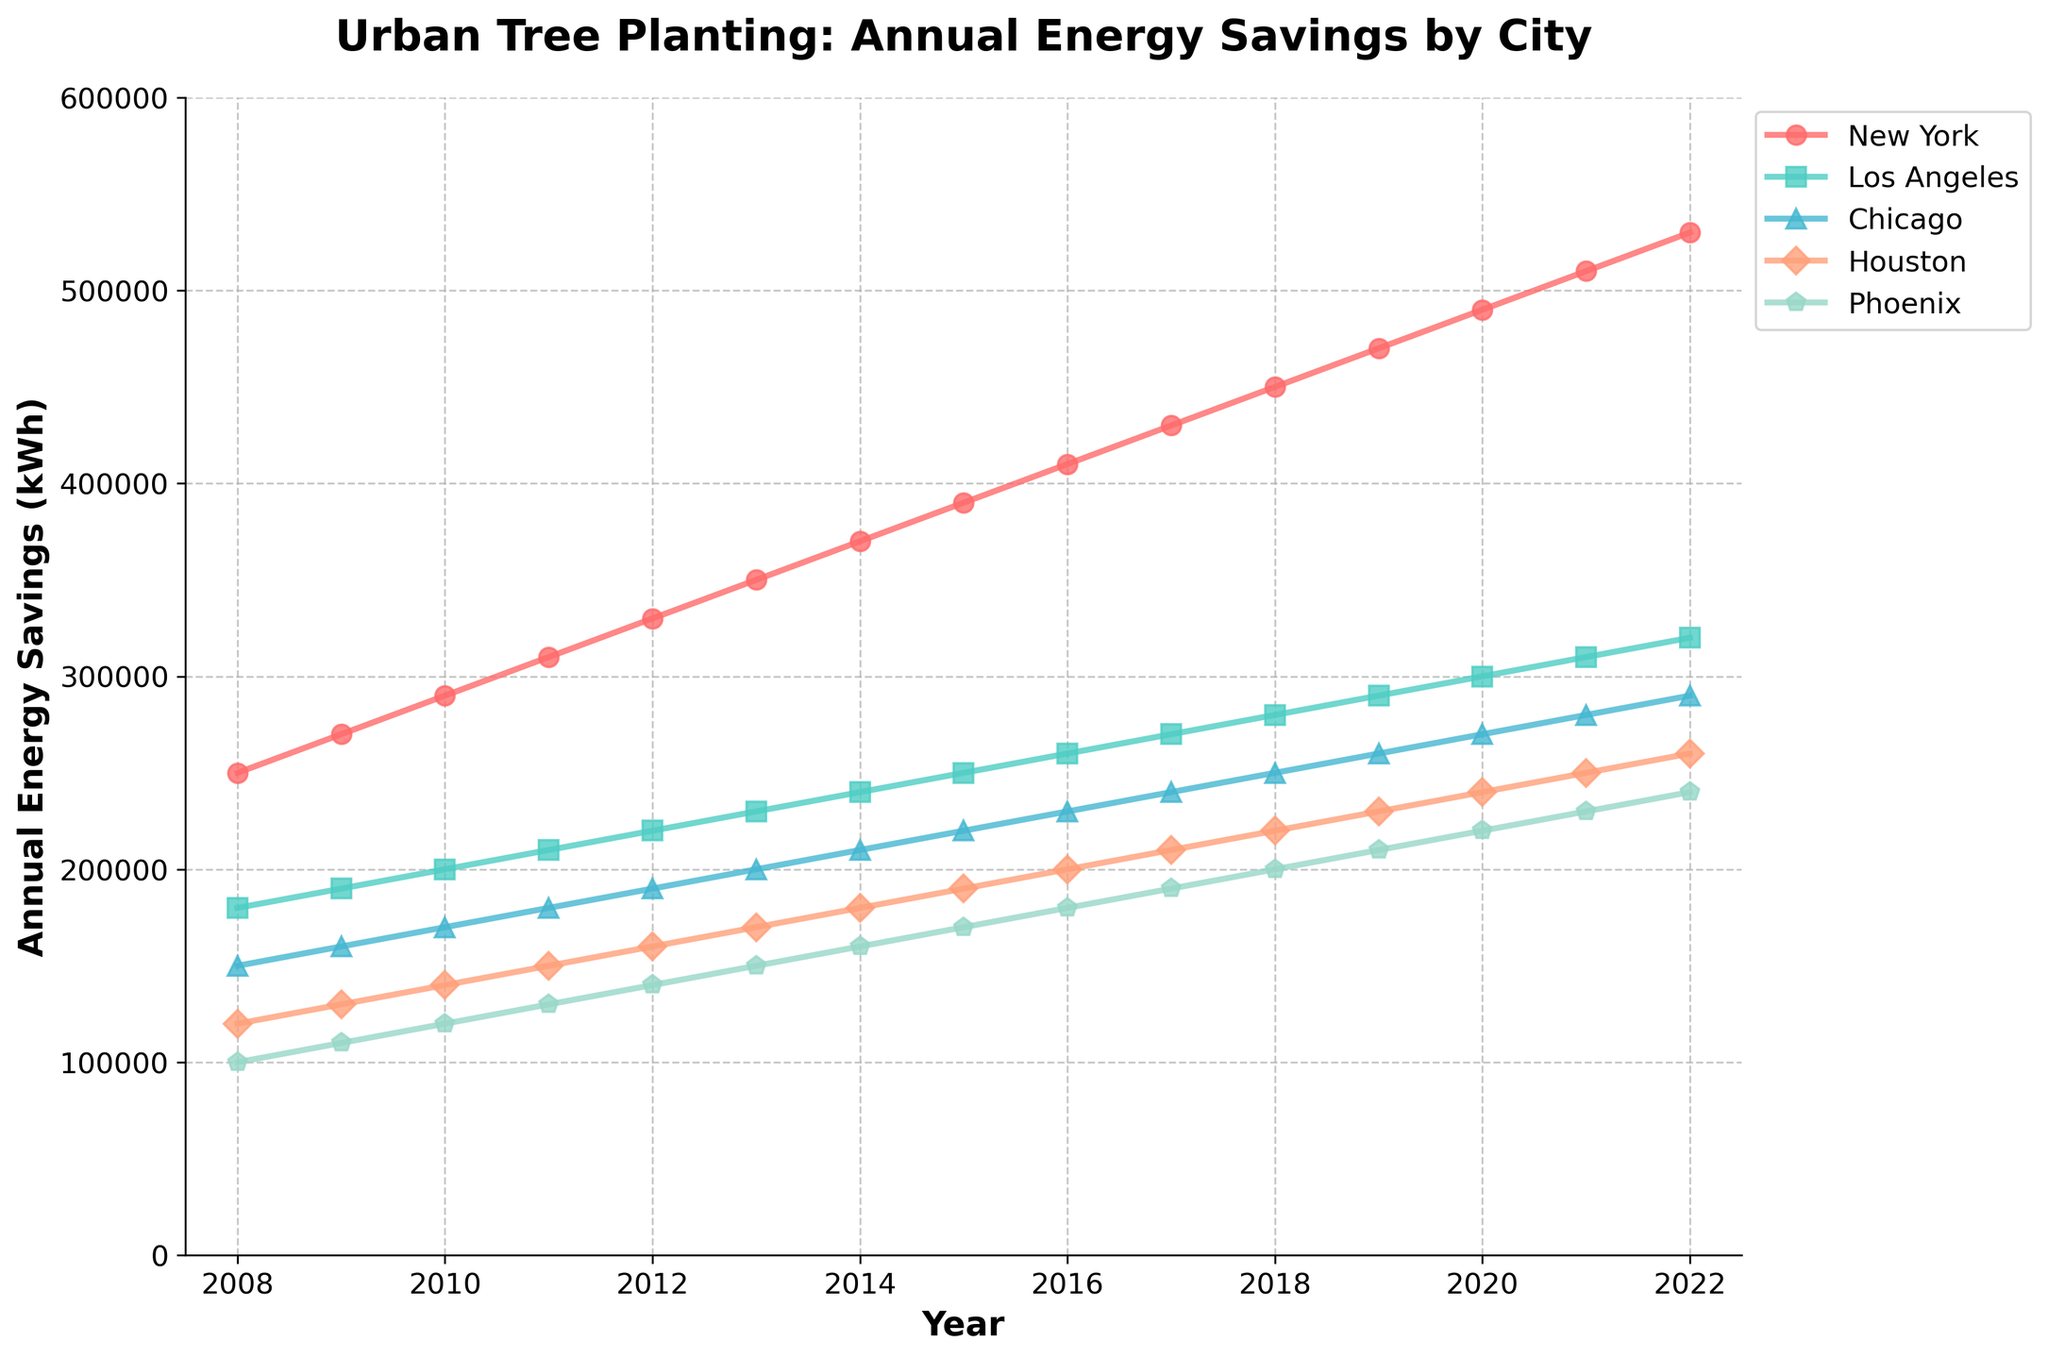What is the title of the figure? The title of the figure is the largest text positioned at the top of the plot, which describes the primary subject of the data being displayed.
Answer: Urban Tree Planting: Annual Energy Savings by City Which city has the highest annual energy savings in 2022? To answer this, look at the endpoint of each line for the year 2022. The highest value on the y-axis corresponds to the city with the maximum savings.
Answer: New York What is the trend of energy savings for Los Angeles from 2008 to 2022? Locate the line representing Los Angeles and observe how it progresses from 2008 to 2022. Identify if it generally increases, decreases or remains the same.
Answer: Increasing Which city has the lowest annual energy savings in 2009? Examine the lines on the plot for the year 2009 and identify the city associated with the lowest point on the y-axis.
Answer: Phoenix What is the difference in annual energy savings between New York and Chicago in 2015? Identify the data points for New York and Chicago in 2015. Subtract the energy savings of Chicago from that of New York for that year.
Answer: 170,000 kWh How has the annual energy savings for Houston changed from 2010 to 2020? Locate the line for Houston and compare its values at the years 2010 and 2020. Observe if the value increases and by how much.
Answer: Increased by 100,000 kWh Which city showed the most consistent increase in energy savings over the 15-year period? Identify the city whose line shows a steady upward trend with minimal variations or deviations, indicating consistency.
Answer: New York How does the annual energy savings in Phoenix in 2014 compare to Los Angeles in 2014? Compare the data points for Phoenix and Los Angeles for the year 2014. Determine which city has a higher value.
Answer: Los Angeles is higher On average, how much annual energy savings do the five cities achieve in 2013? Sum the annual energy savings for all five cities in 2013 and divide by the number of cities (5).
Answer: 220,000 kWh Which city saw the highest growth in annual energy savings from 2008 to 2022? Compare the difference in annual energy savings from 2008 to 2022 for each city. The city with the largest increase in value has the highest growth.
Answer: New York 